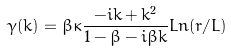<formula> <loc_0><loc_0><loc_500><loc_500>\gamma ( k ) = \beta \kappa \frac { - i k + k ^ { 2 } } { 1 - \beta - i \beta k } L n ( r / L )</formula> 